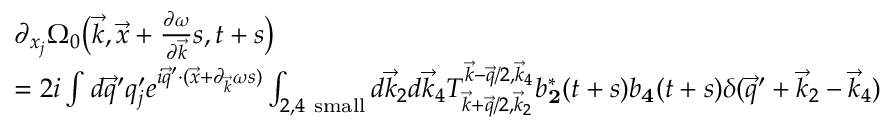Convert formula to latex. <formula><loc_0><loc_0><loc_500><loc_500>\begin{array} { r l } & { \partial _ { { x } _ { j } } \Omega _ { 0 } \left ( \vec { k } , \vec { x } + \frac { \partial \omega } { \partial \vec { k } } s , t + s \right ) } \\ & { = 2 i \int d \vec { q } ^ { \prime } q _ { j } ^ { \prime } e ^ { i \vec { q } ^ { \prime } \cdot ( \vec { x } + \partial _ { \vec { k } } \omega s ) } \int _ { 2 , 4 s m a l l } d \vec { k } _ { 2 } d \vec { k } _ { 4 } T _ { \vec { k } + \vec { q } / 2 , \vec { k } _ { 2 } } ^ { \vec { k } - \vec { q } / 2 , \vec { k } _ { 4 } } b _ { \mathbf 2 } ^ { * } ( t + s ) b _ { \mathbf 4 } ( t + s ) \delta ( \vec { q } ^ { \prime } + \vec { k } _ { 2 } - \vec { k } _ { 4 } ) } \end{array}</formula> 